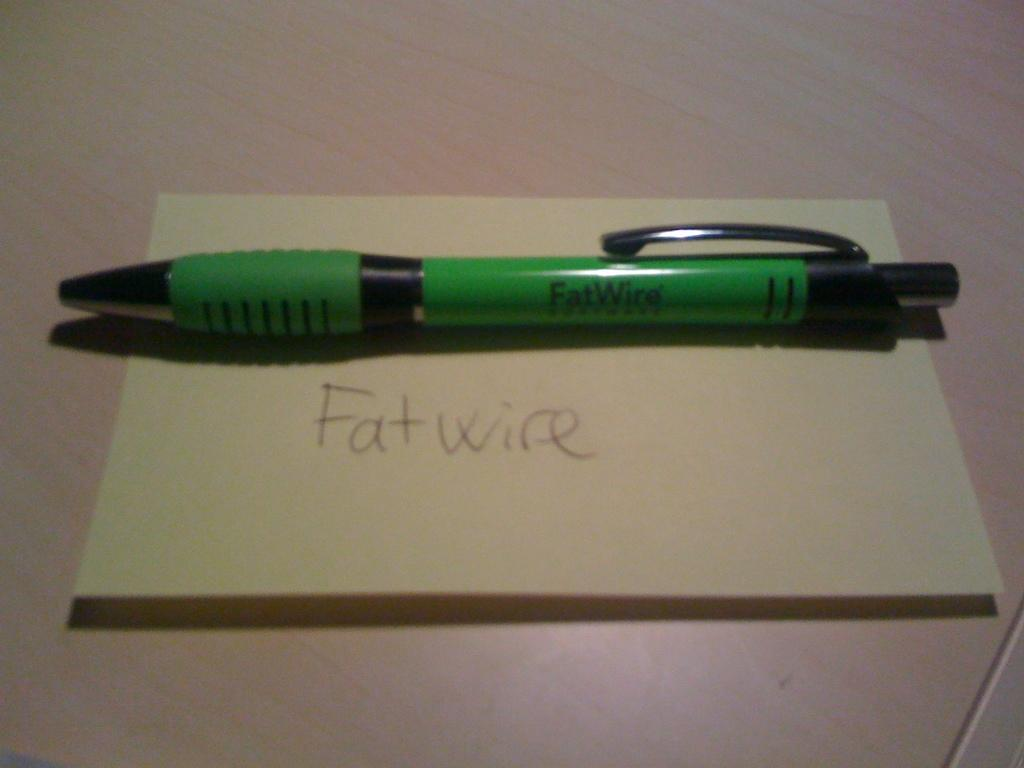What object is present in the image that is commonly used for writing? There is a pen in the image. Where is the pen located in the image? The pen is on a paper. What can be found on the paper that the pen is resting on? The paper contains written text. What type of coat is being worn by the pig in the image? There are no pigs or coats present in the image; it only features a pen on a paper with written text. 